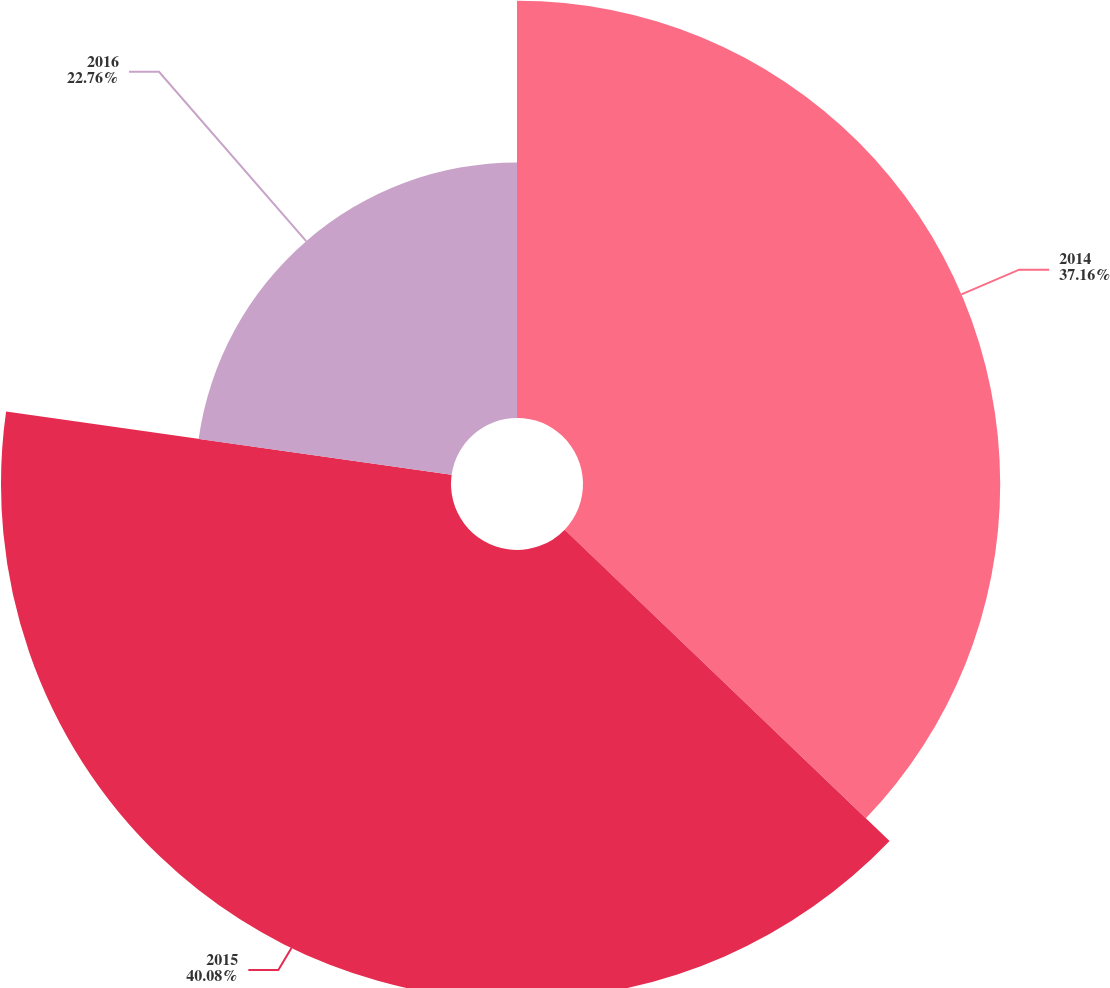Convert chart. <chart><loc_0><loc_0><loc_500><loc_500><pie_chart><fcel>2014<fcel>2015<fcel>2016<nl><fcel>37.16%<fcel>40.08%<fcel>22.76%<nl></chart> 